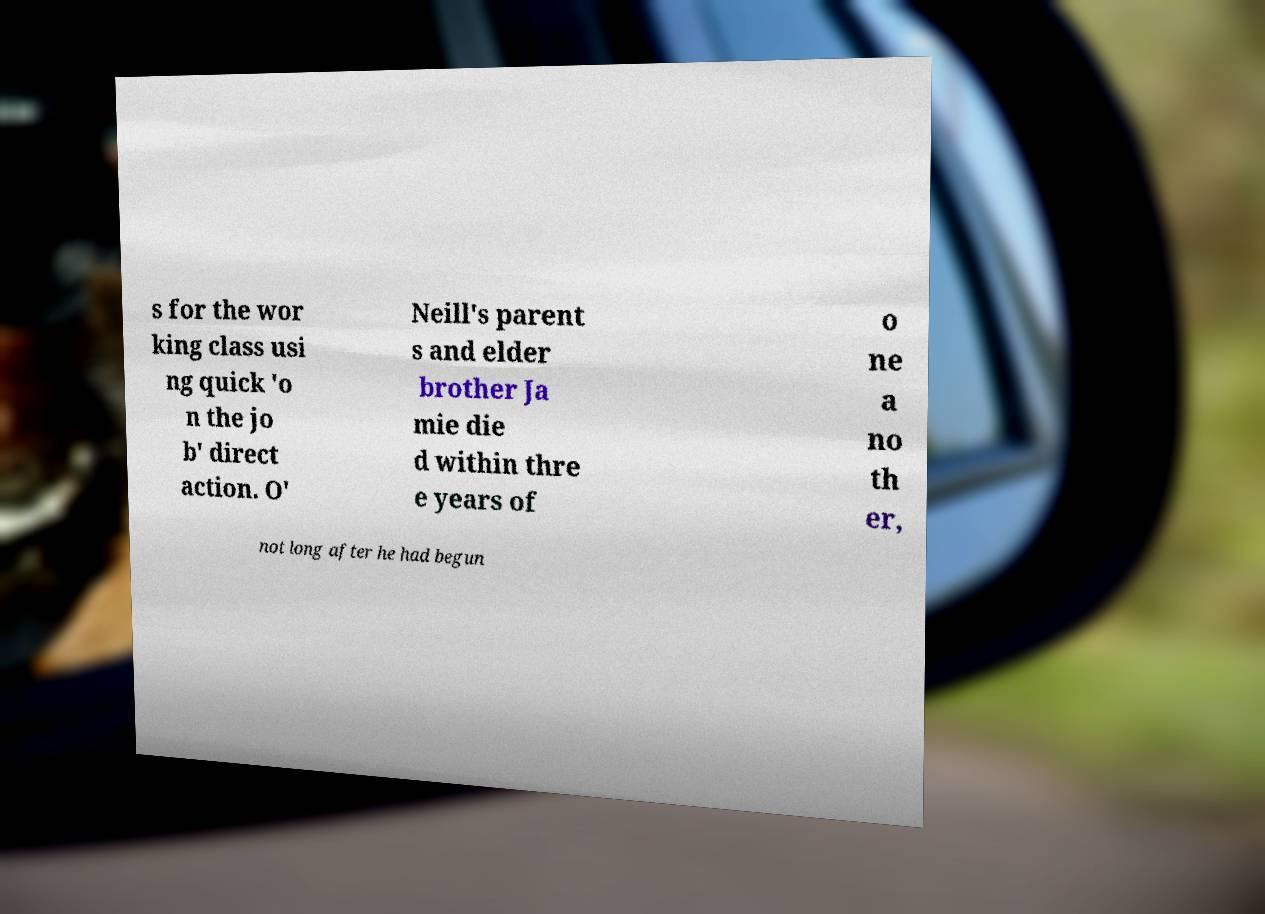What messages or text are displayed in this image? I need them in a readable, typed format. s for the wor king class usi ng quick 'o n the jo b' direct action. O' Neill's parent s and elder brother Ja mie die d within thre e years of o ne a no th er, not long after he had begun 